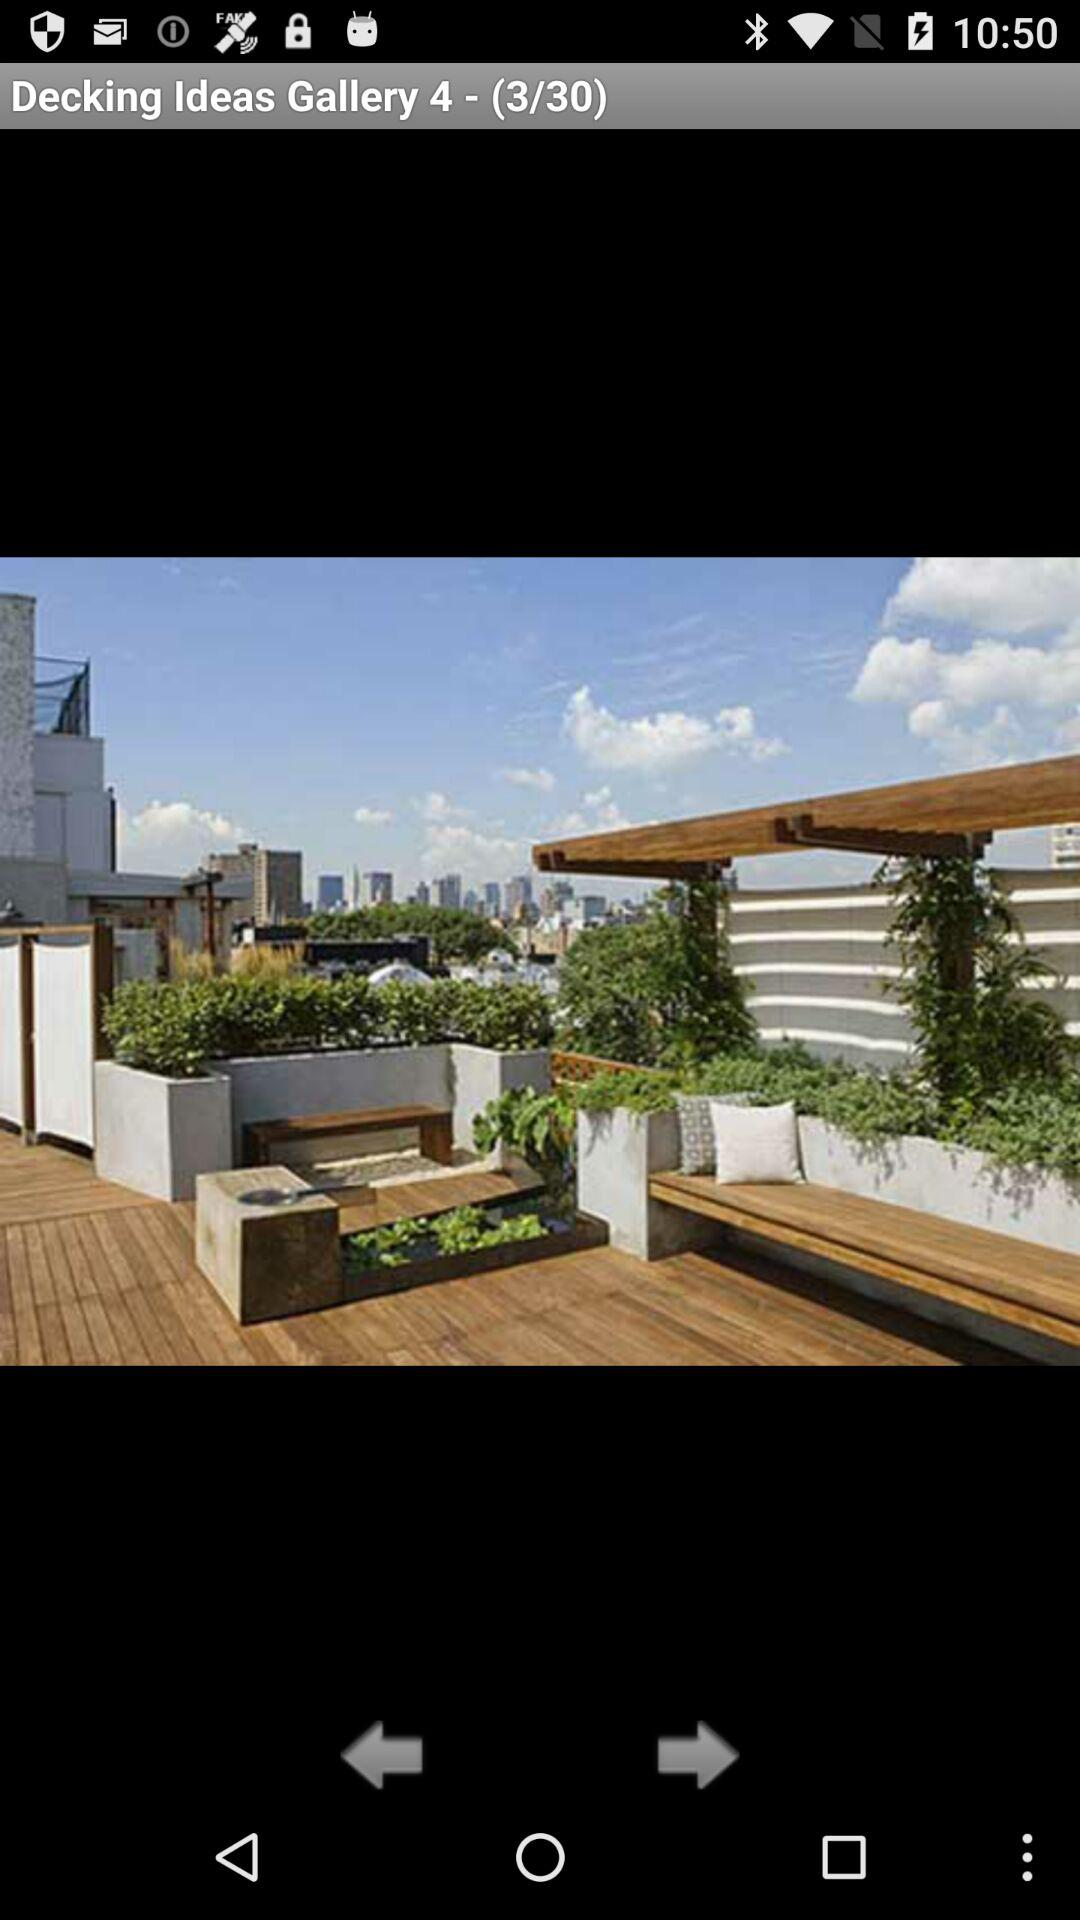How many images in total are there? There are 30 images in total. 